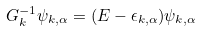Convert formula to latex. <formula><loc_0><loc_0><loc_500><loc_500>G ^ { - 1 } _ { k } \psi _ { k , \alpha } = ( E - \epsilon _ { k , \alpha } ) \psi _ { k , \alpha }</formula> 